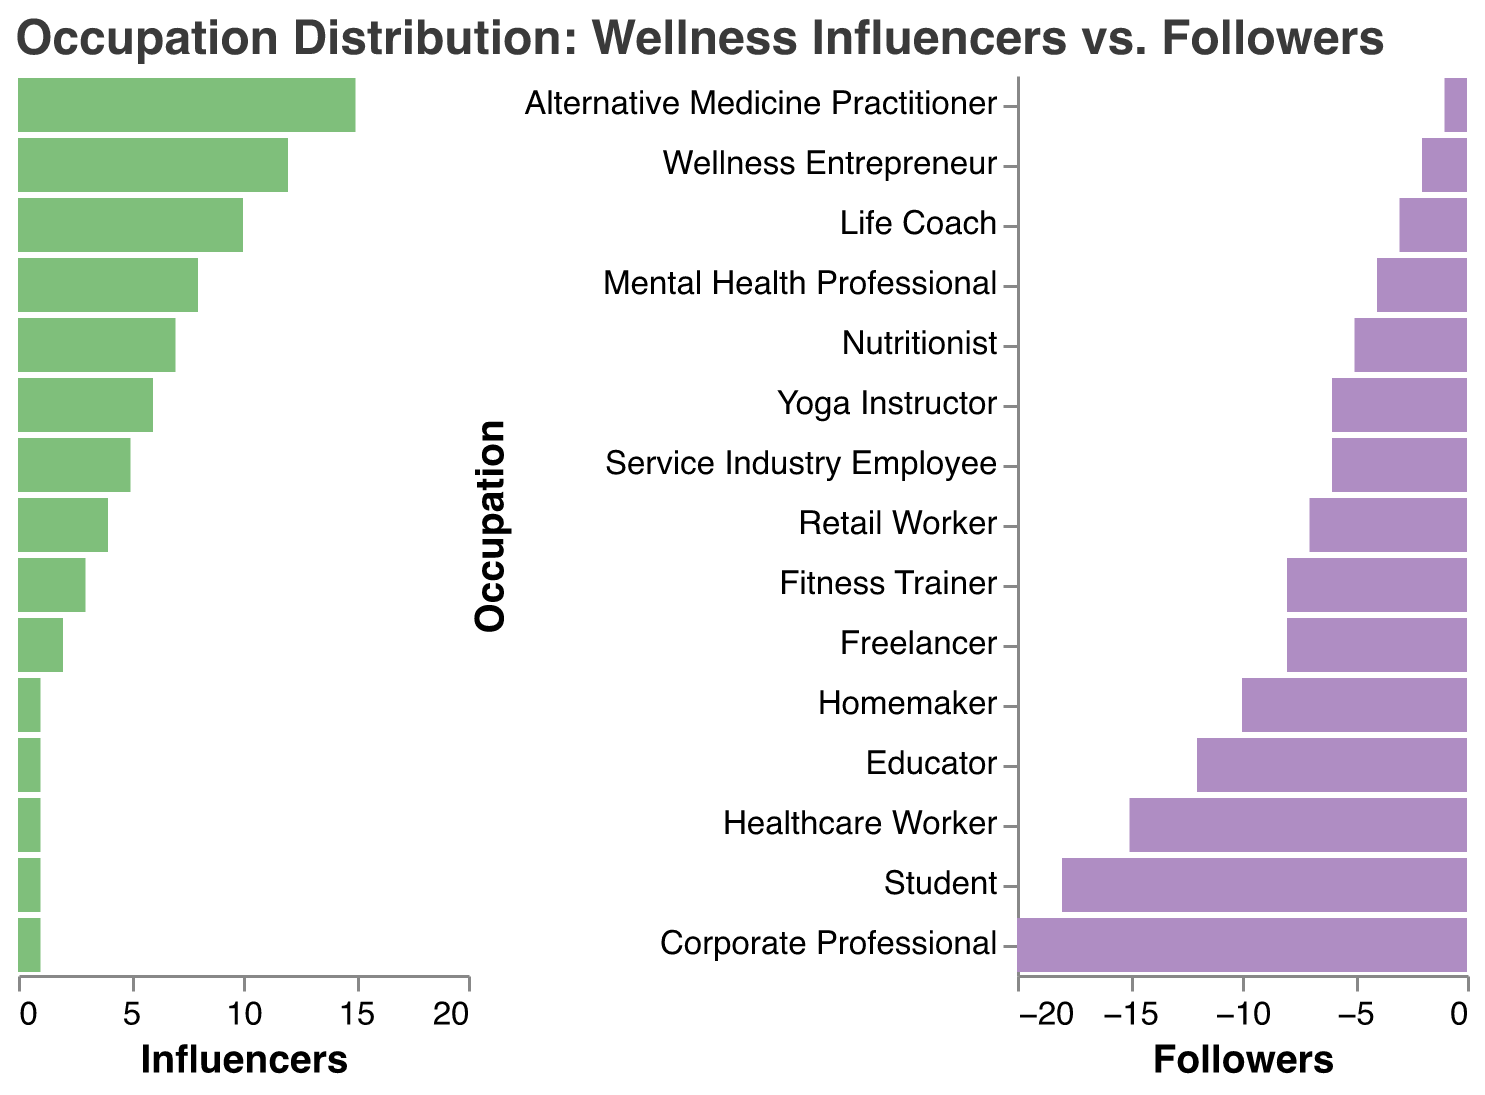What is the title of the figure? The title is displayed at the top of the figure and it reads "Occupation Distribution: Wellness Influencers vs. Followers".
Answer: Occupation Distribution: Wellness Influencers vs. Followers How many occupations are displayed in the figure? There are 15 different occupations listed on the y-axis of the figure.
Answer: 15 Which occupation has the highest number of influencers? By observing the length of the green bars representing influencers, the "Fitness Trainer" occupation has the highest value.
Answer: Fitness Trainer How many followers are identified as Corporate Professionals? The value for Corporate Professionals among followers is represented by the corresponding pink bar and it measures -20.
Answer: 20 Compare the number of influencers and followers in the "Nutritionist" occupation. "Nutritionist" influencers are 12, as seen from the length of the green bar, while followers are -5 as represented by the pink bar.
Answer: Influencers: 12, Followers: 5 Which occupation has the biggest discrepancy between influencers and followers? By comparing the lengths of the green and pink bars across all occupations, the "Corporate Professional" shows the largest difference where Influencers are 4 and Followers are -20, disparity of 24.
Answer: Corporate Professional What is the total number of influencers in the listed occupations? Sum the influencer values for all occupations: 15 + 12 + 10 + 8 + 7 + 6 + 5 + 4 + 3 + 2 + 1 + 1 + 1 + 1 + 1 = 76
Answer: 76 What is the median number of followers across all occupations? To find the median, list the follower counts in ascending order and find the middle value: -20, -18, -15, -12, -10, -8, -8, -7, -6, -6, -5, -4, -3, -2, -1. The median is -6.
Answer: -6 How does the number of "Students" as followers compare to "Students" as influencers? The bar for "Students" as followers is -18 and for influencers it is 1, showing a larger number of followers.
Answer: More Followers: 18 vs 1 Which occupations have an equal number of influencers? Observing the length of the green bars, "Student", "Homemaker", "Freelancer", "Retail Worker", and "Service Industry Employee" all have equal values of 1.
Answer: Student, Homemaker, Freelancer, Retail Worker, Service Industry Employee 